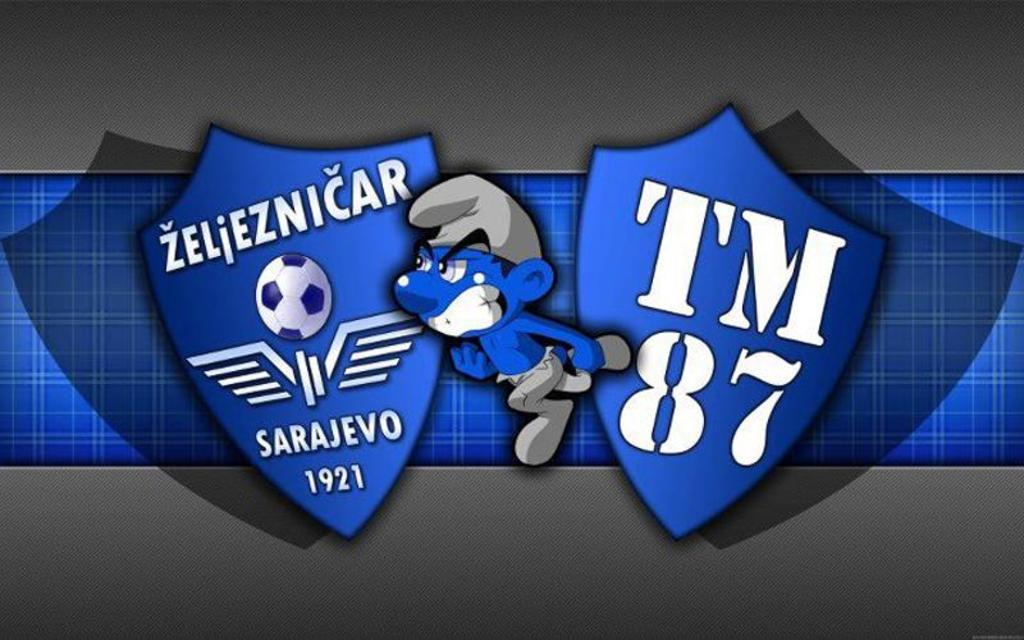How has the image been altered or modified? The image is edited. What is the main subject in the center of the image? There is a cartoon in the center of the image. What other elements are present in the image besides the cartoon? There are logos with text in the image. What type of game is being played in the jail depicted in the image? There is no jail or game present in the image; it features an edited cartoon and logos with text. 